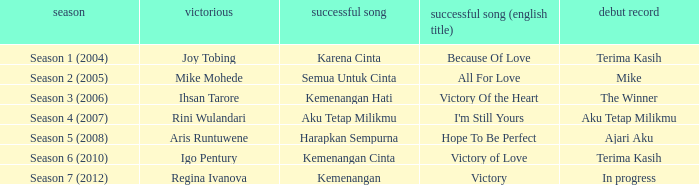Which winning song had a debut album in progress? Kemenangan. 